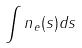Convert formula to latex. <formula><loc_0><loc_0><loc_500><loc_500>\int n _ { e } ( s ) d s</formula> 